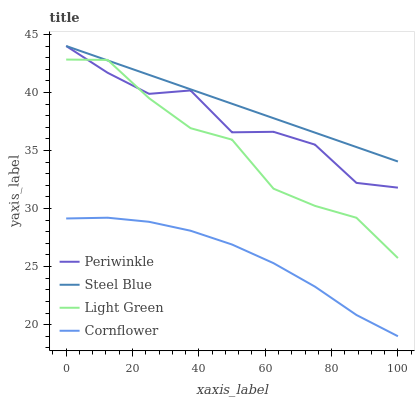Does Cornflower have the minimum area under the curve?
Answer yes or no. Yes. Does Steel Blue have the maximum area under the curve?
Answer yes or no. Yes. Does Periwinkle have the minimum area under the curve?
Answer yes or no. No. Does Periwinkle have the maximum area under the curve?
Answer yes or no. No. Is Steel Blue the smoothest?
Answer yes or no. Yes. Is Periwinkle the roughest?
Answer yes or no. Yes. Is Periwinkle the smoothest?
Answer yes or no. No. Is Steel Blue the roughest?
Answer yes or no. No. Does Periwinkle have the lowest value?
Answer yes or no. No. Does Light Green have the highest value?
Answer yes or no. No. Is Cornflower less than Periwinkle?
Answer yes or no. Yes. Is Steel Blue greater than Cornflower?
Answer yes or no. Yes. Does Cornflower intersect Periwinkle?
Answer yes or no. No. 